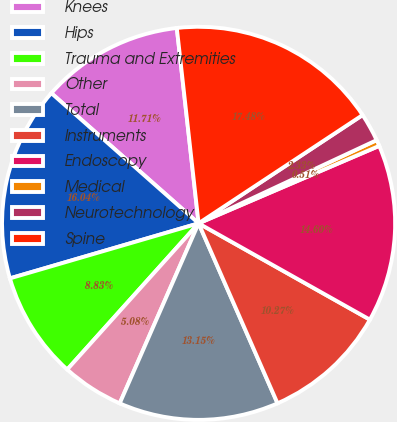Convert chart. <chart><loc_0><loc_0><loc_500><loc_500><pie_chart><fcel>Knees<fcel>Hips<fcel>Trauma and Extremities<fcel>Other<fcel>Total<fcel>Instruments<fcel>Endoscopy<fcel>Medical<fcel>Neurotechnology<fcel>Spine<nl><fcel>11.71%<fcel>16.04%<fcel>8.83%<fcel>5.08%<fcel>13.15%<fcel>10.27%<fcel>14.6%<fcel>0.51%<fcel>2.33%<fcel>17.48%<nl></chart> 